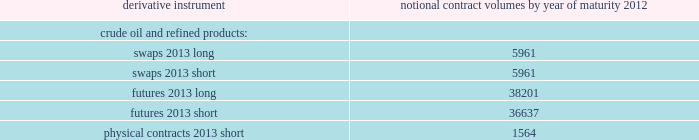Table of contents valero energy corporation and subsidiaries notes to consolidated financial statements ( continued ) cash flow hedges cash flow hedges are used to hedge price volatility in certain forecasted feedstock and refined product purchases , refined product sales , and natural gas purchases .
The objective of our cash flow hedges is to lock in the price of forecasted feedstock , product or natural gas purchases or refined product sales at existing market prices that we deem favorable .
As of december 31 , 2011 , we had the following outstanding commodity derivative instruments that were entered into to hedge forecasted purchases or sales of crude oil and refined products .
The information presents the notional volume of outstanding contracts by type of instrument and year of maturity ( volumes in thousands of barrels ) .
Notional contract volumes by year of maturity derivative instrument 2012 .

What is the ratio of short physical contracts to long futures notional contracts? 
Computations: (1564 / 38201)
Answer: 0.04094. 